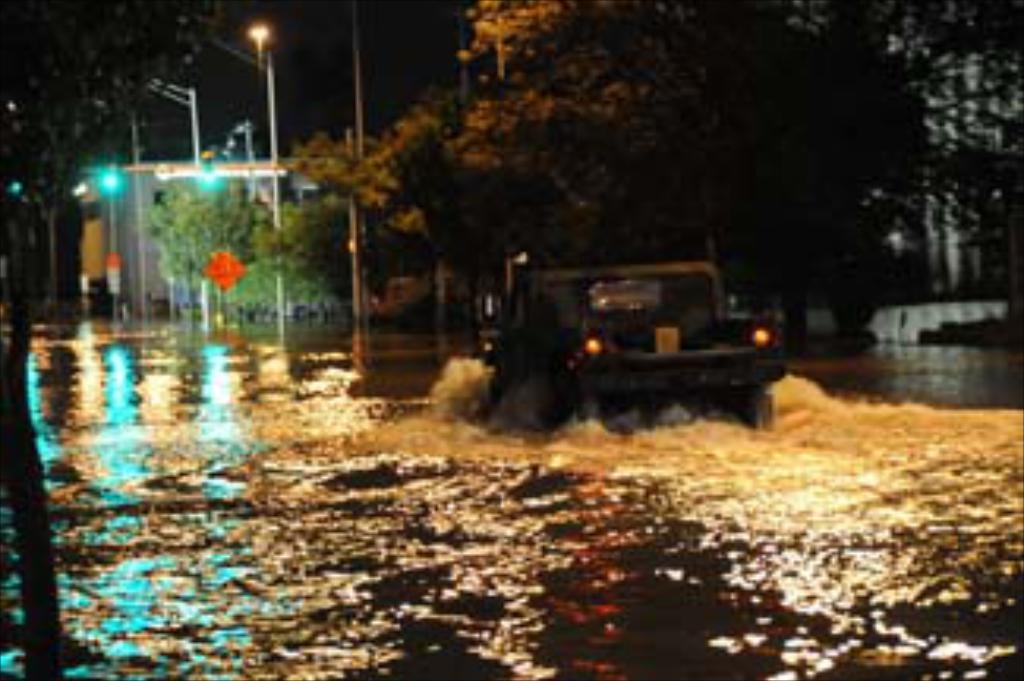What is the main subject of the image? There is a vehicle in the water. What can be seen in the background of the image? There are trees and light poles in the background of the image. What is the color of the sky in the image? The sky appears to be black in color. What month is it in the image? The month cannot be determined from the image, as there is no information about the time of year. 